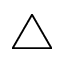Convert formula to latex. <formula><loc_0><loc_0><loc_500><loc_500>\bigtriangleup</formula> 